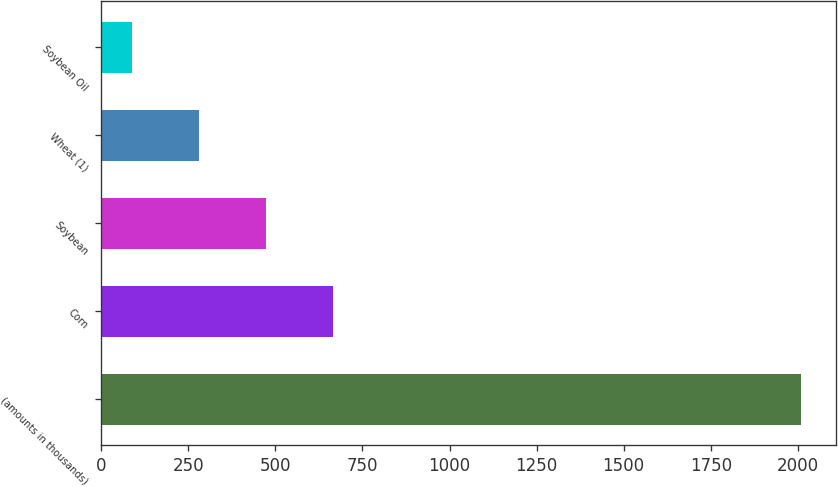<chart> <loc_0><loc_0><loc_500><loc_500><bar_chart><fcel>(amounts in thousands)<fcel>Corn<fcel>Soybean<fcel>Wheat (1)<fcel>Soybean Oil<nl><fcel>2010<fcel>665.3<fcel>473.2<fcel>281.1<fcel>89<nl></chart> 